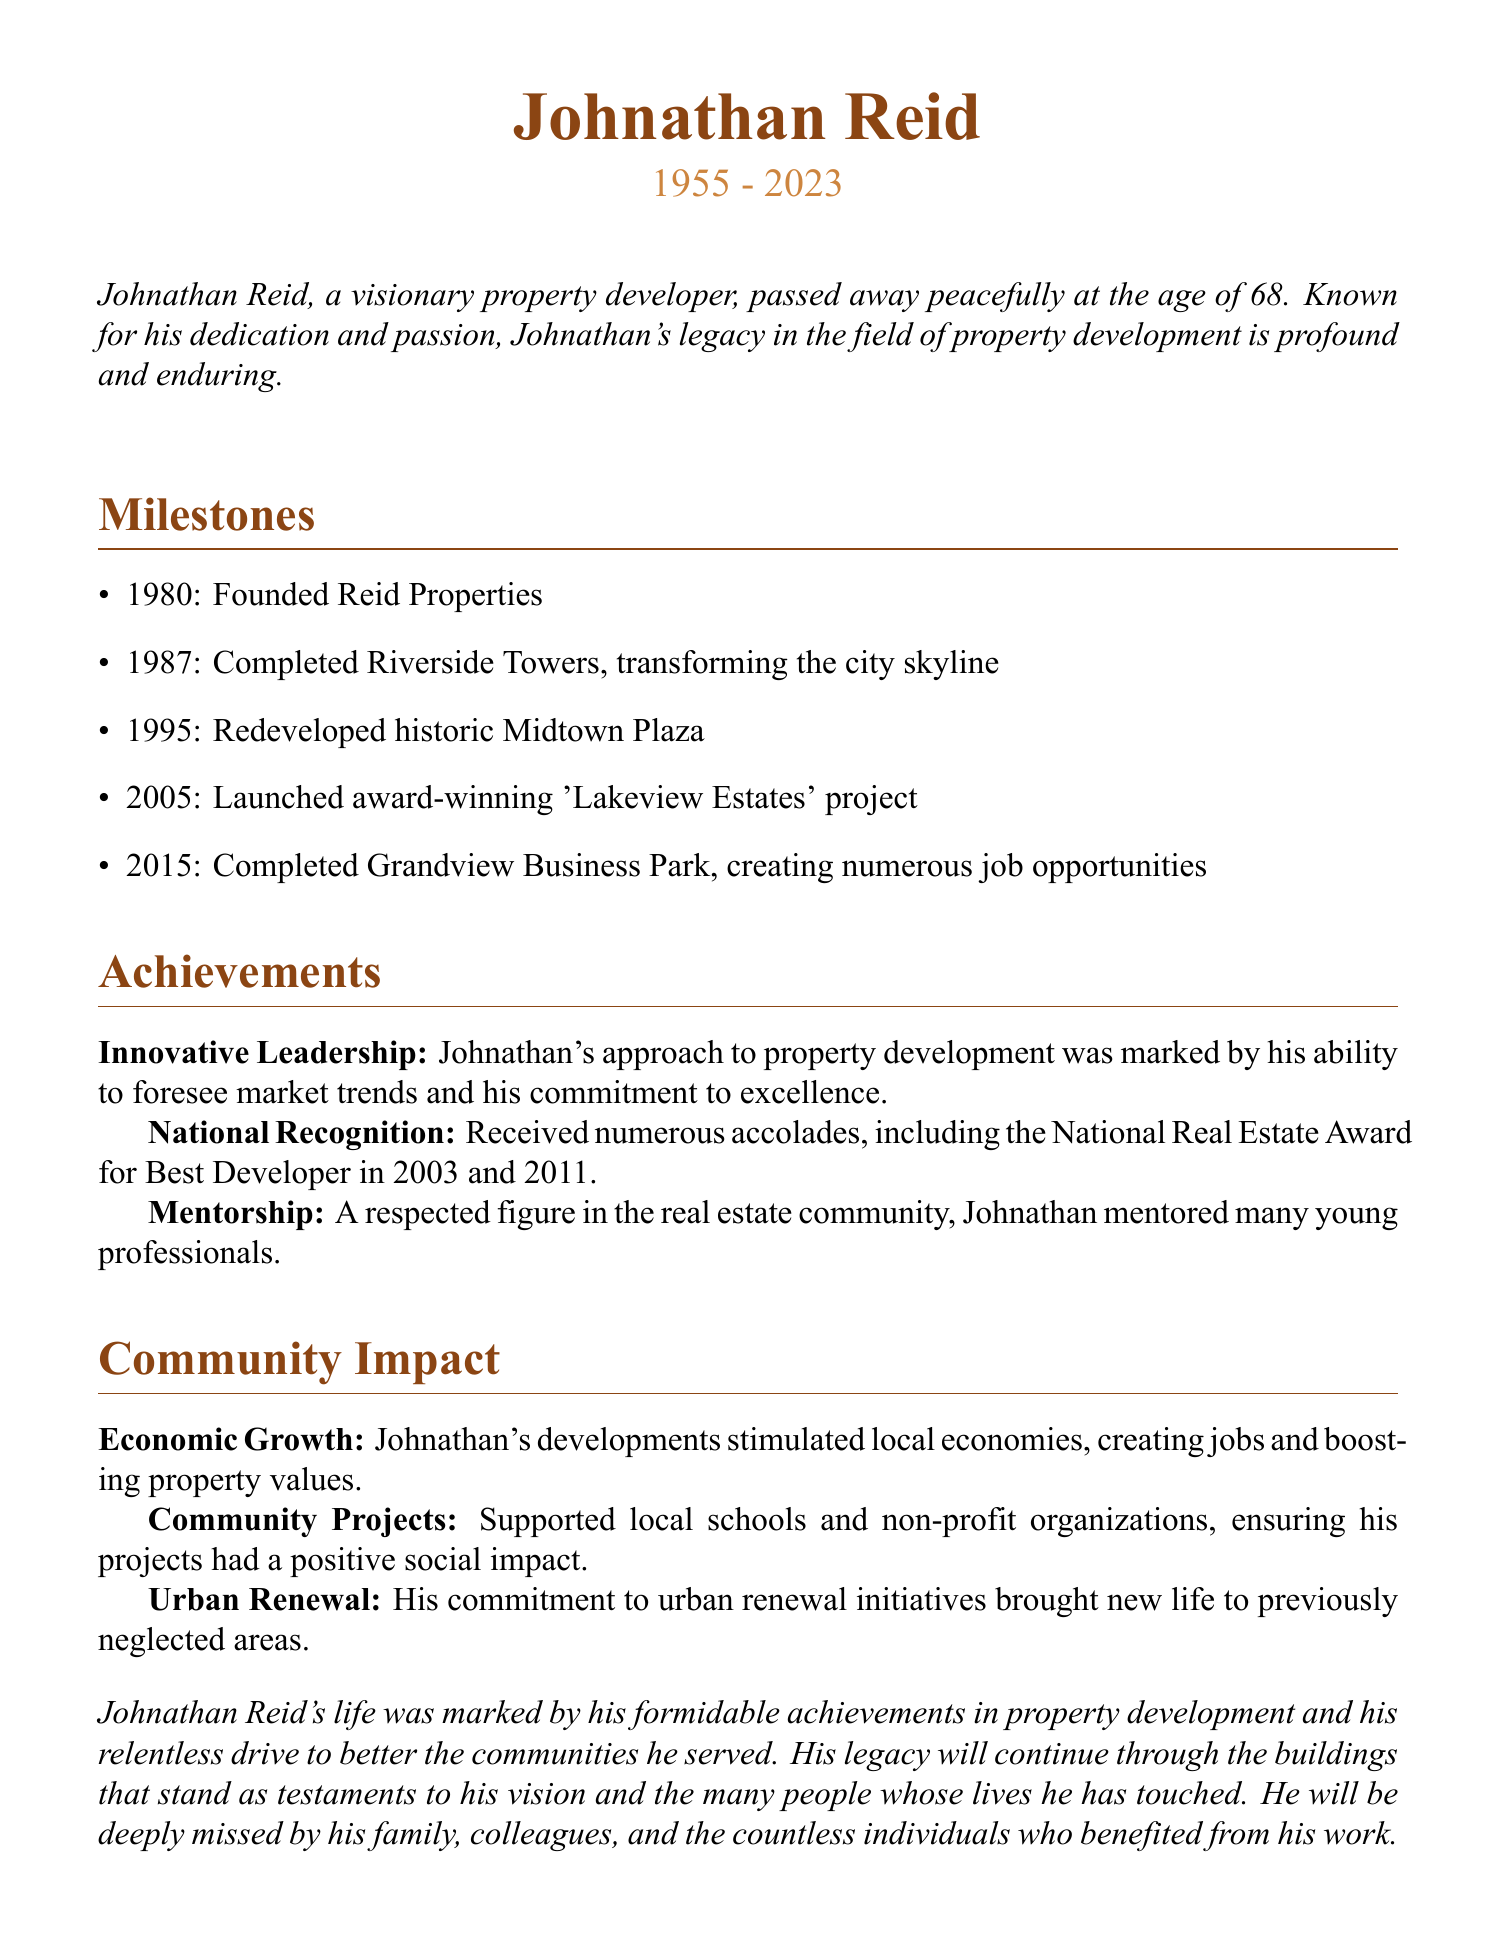What was Johnathan Reid's age at the time of his passing? The document states that Johnathan Reid passed away at the age of 68.
Answer: 68 When did Johnathan found Reid Properties? According to the milestones listed, Reid Properties was founded in 1980.
Answer: 1980 What project was completed in 1995? The document mentions that the historic Midtown Plaza was redeveloped in 1995.
Answer: Midtown Plaza How many times did Johnathan receive the National Real Estate Award for Best Developer? The achievements section indicates he received this award twice, in 2003 and 2011.
Answer: Twice What significant project did Johnathan complete in 2015? The Grandview Business Park was completed in 2015, as noted in the milestones.
Answer: Grandview Business Park What type of impact did Johnathan's developments have on local economies? The document mentions that his developments stimulated local economies.
Answer: Stimulated local economies Which project transformed the city skyline? Riverside Towers, as noted in the milestones, transformed the city skyline upon completion.
Answer: Riverside Towers What was a key aspect of Johnathan's leadership style? He was marked by his ability to foresee market trends, as stated in the achievements section.
Answer: Foreseeing market trends 